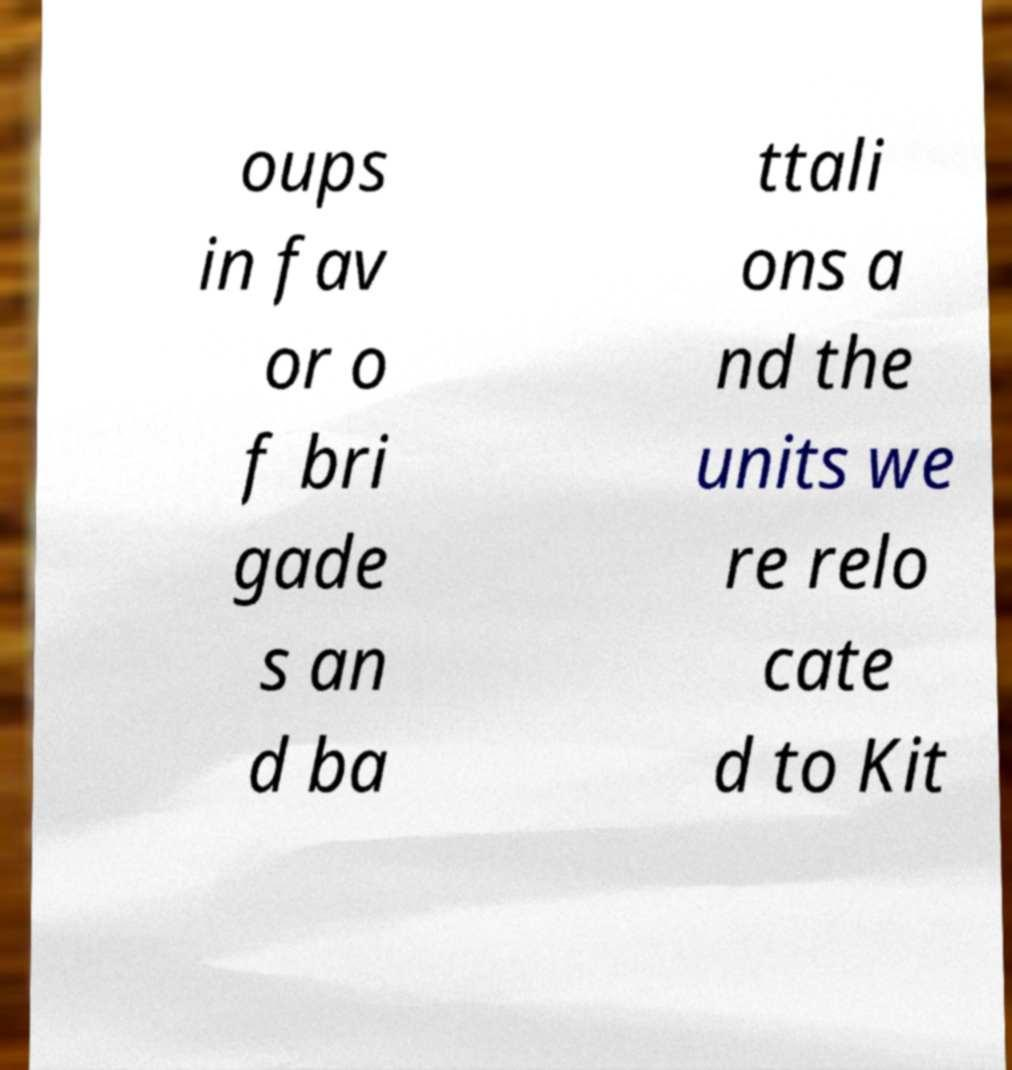Could you assist in decoding the text presented in this image and type it out clearly? oups in fav or o f bri gade s an d ba ttali ons a nd the units we re relo cate d to Kit 